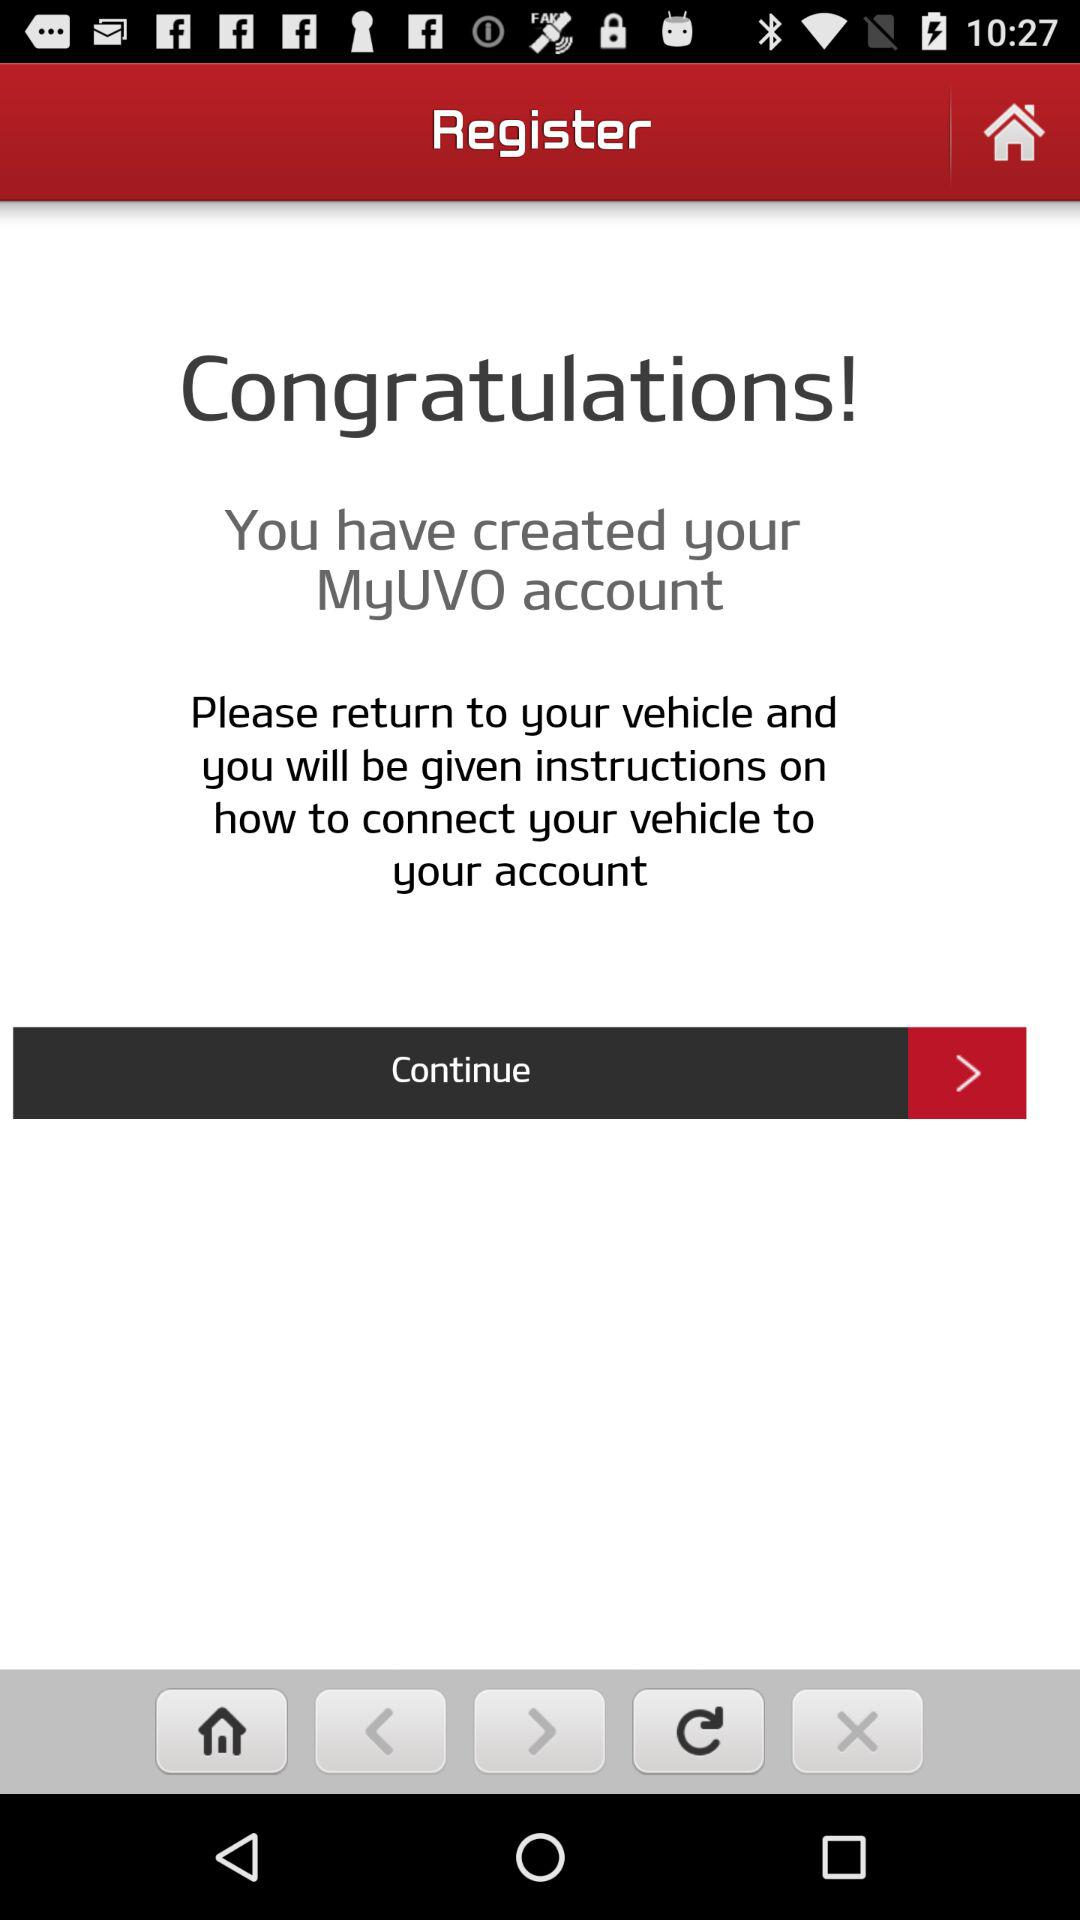What is the app name? The app name is "MyUVO". 